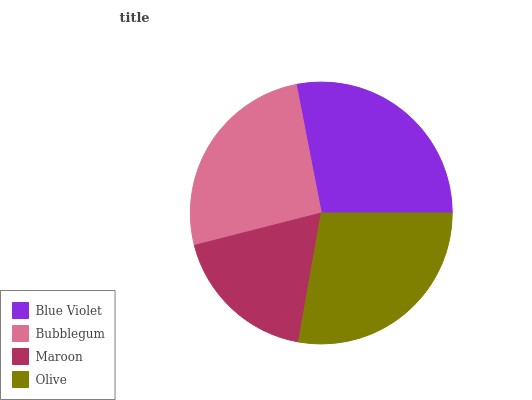Is Maroon the minimum?
Answer yes or no. Yes. Is Blue Violet the maximum?
Answer yes or no. Yes. Is Bubblegum the minimum?
Answer yes or no. No. Is Bubblegum the maximum?
Answer yes or no. No. Is Blue Violet greater than Bubblegum?
Answer yes or no. Yes. Is Bubblegum less than Blue Violet?
Answer yes or no. Yes. Is Bubblegum greater than Blue Violet?
Answer yes or no. No. Is Blue Violet less than Bubblegum?
Answer yes or no. No. Is Olive the high median?
Answer yes or no. Yes. Is Bubblegum the low median?
Answer yes or no. Yes. Is Bubblegum the high median?
Answer yes or no. No. Is Olive the low median?
Answer yes or no. No. 